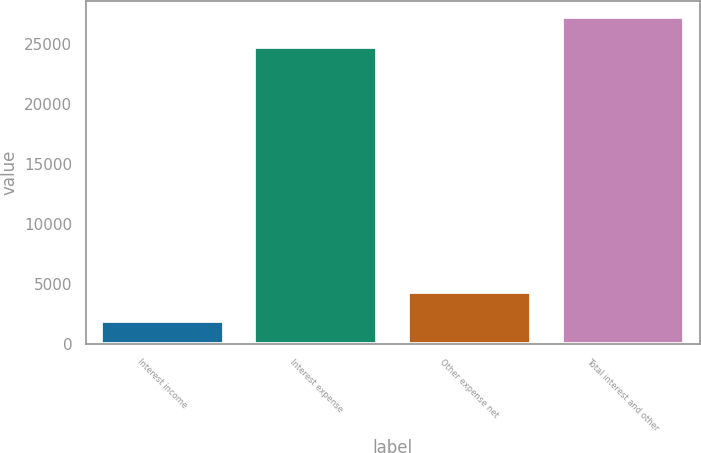Convert chart to OTSL. <chart><loc_0><loc_0><loc_500><loc_500><bar_chart><fcel>Interest income<fcel>Interest expense<fcel>Other expense net<fcel>Total interest and other<nl><fcel>1884<fcel>24783<fcel>4373<fcel>27272<nl></chart> 